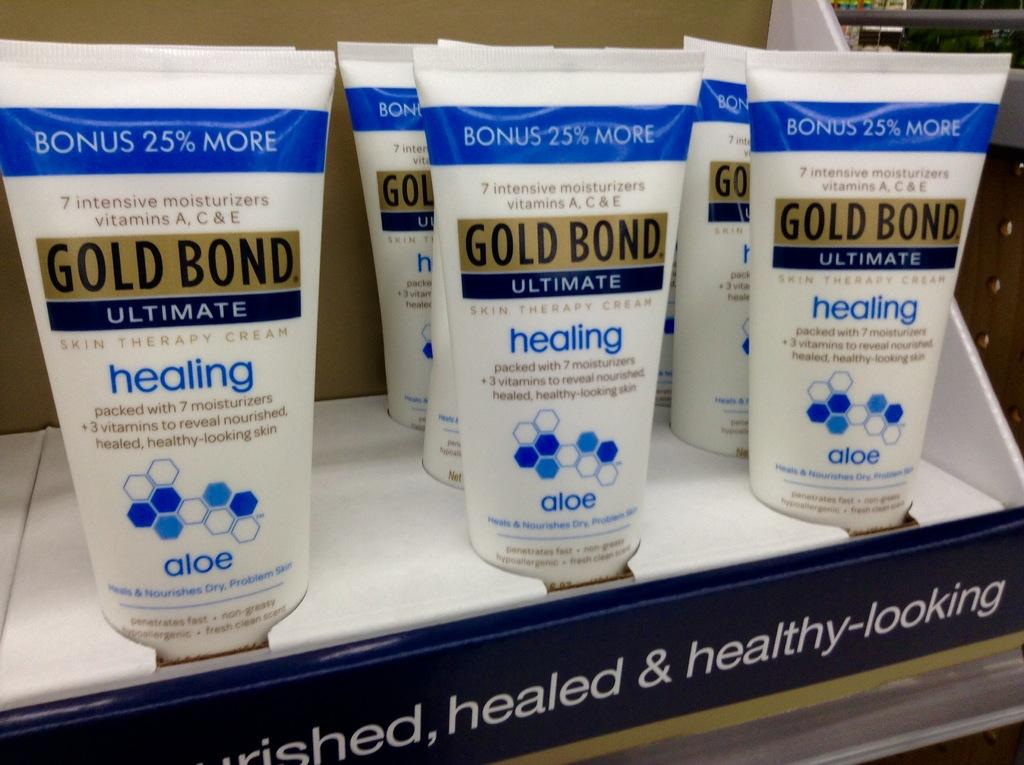Provide a one-sentence caption for the provided image. A display case is full of Gold Bond cream. 